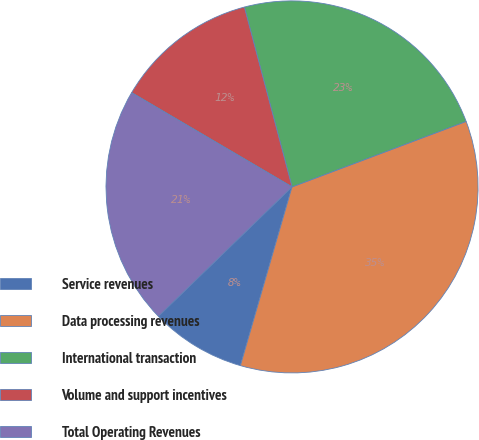<chart> <loc_0><loc_0><loc_500><loc_500><pie_chart><fcel>Service revenues<fcel>Data processing revenues<fcel>International transaction<fcel>Volume and support incentives<fcel>Total Operating Revenues<nl><fcel>8.28%<fcel>35.2%<fcel>23.4%<fcel>12.42%<fcel>20.7%<nl></chart> 